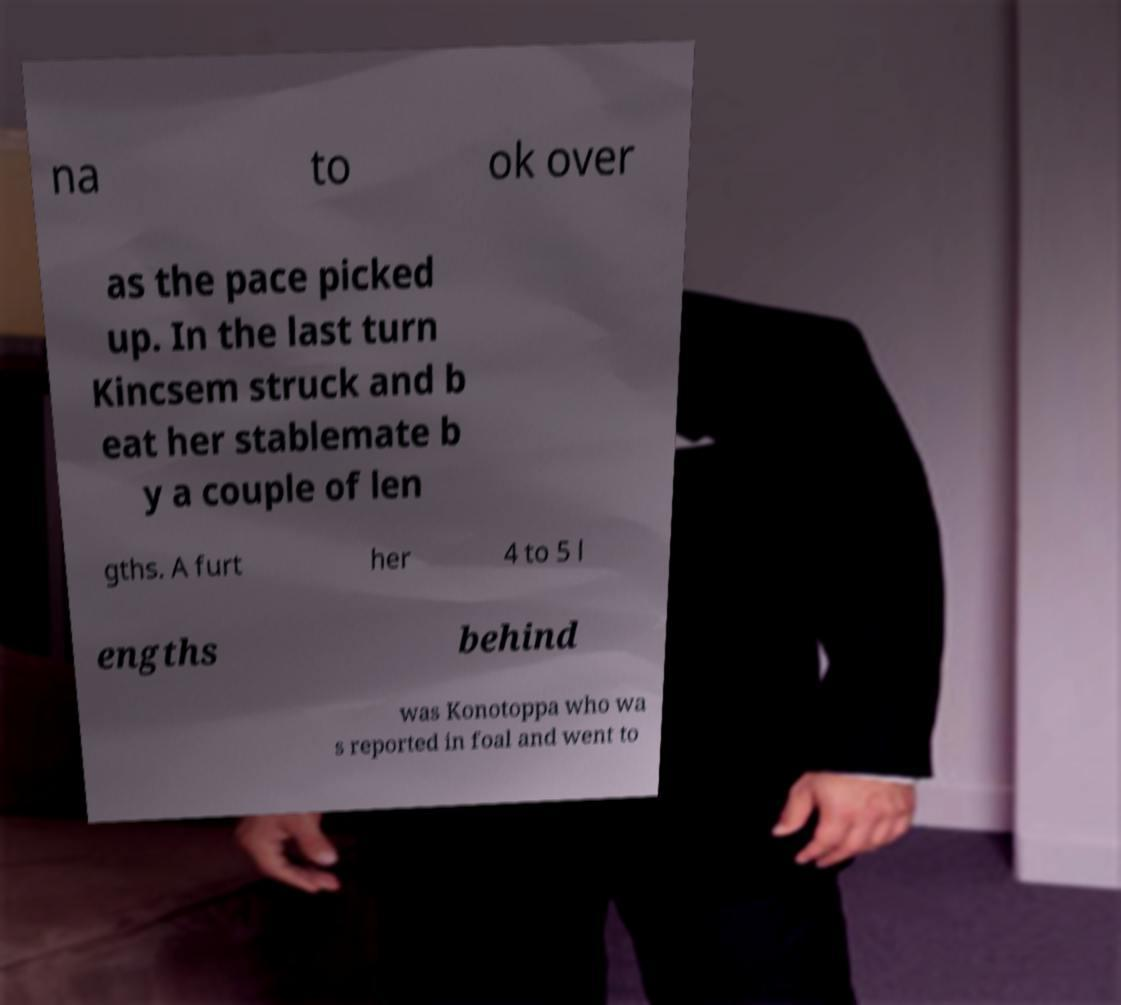Can you read and provide the text displayed in the image?This photo seems to have some interesting text. Can you extract and type it out for me? na to ok over as the pace picked up. In the last turn Kincsem struck and b eat her stablemate b y a couple of len gths. A furt her 4 to 5 l engths behind was Konotoppa who wa s reported in foal and went to 